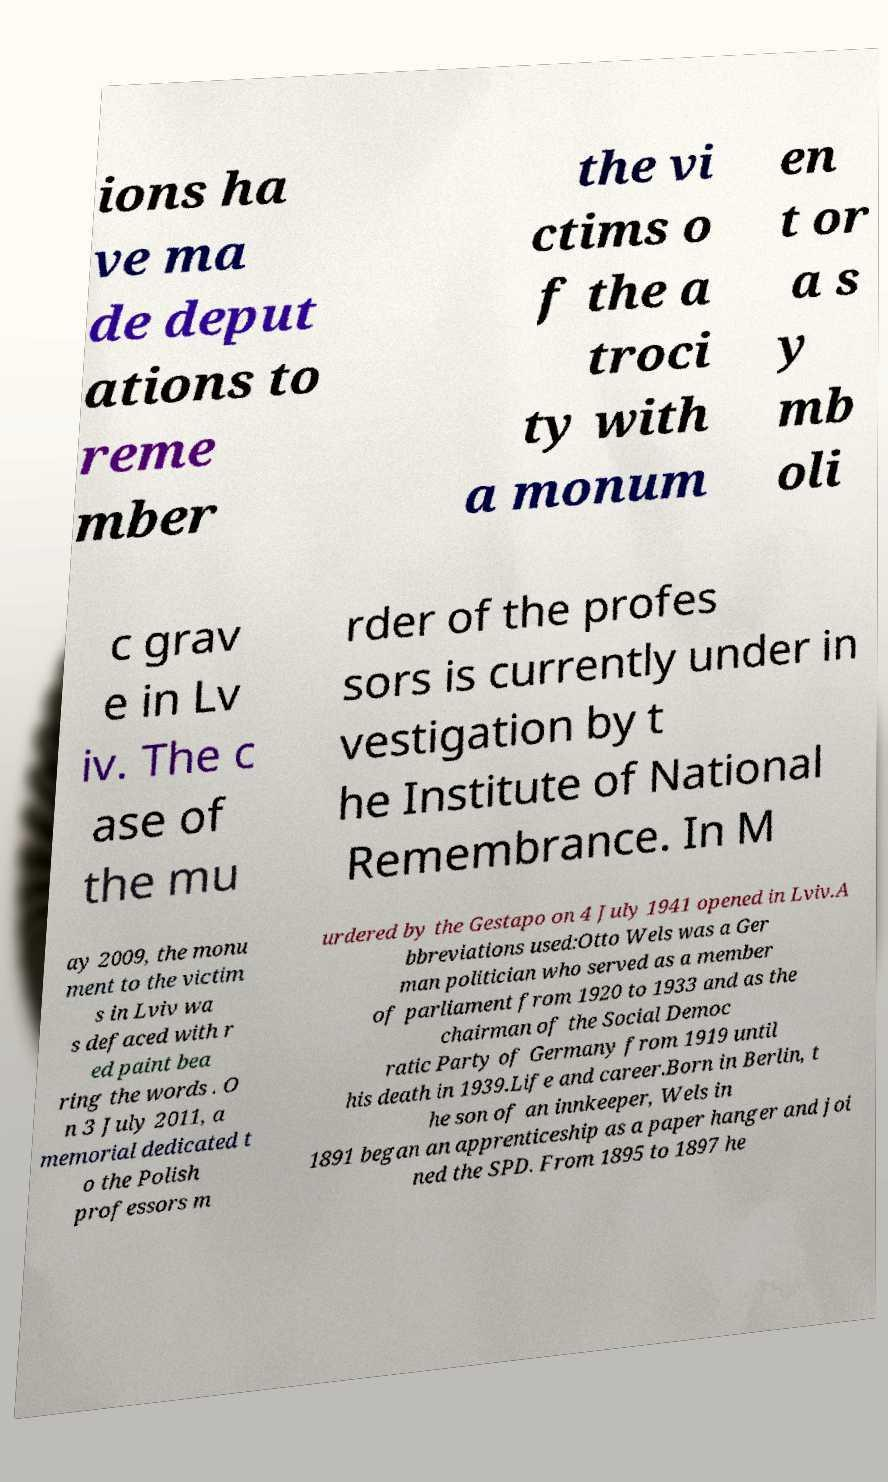There's text embedded in this image that I need extracted. Can you transcribe it verbatim? ions ha ve ma de deput ations to reme mber the vi ctims o f the a troci ty with a monum en t or a s y mb oli c grav e in Lv iv. The c ase of the mu rder of the profes sors is currently under in vestigation by t he Institute of National Remembrance. In M ay 2009, the monu ment to the victim s in Lviv wa s defaced with r ed paint bea ring the words . O n 3 July 2011, a memorial dedicated t o the Polish professors m urdered by the Gestapo on 4 July 1941 opened in Lviv.A bbreviations used:Otto Wels was a Ger man politician who served as a member of parliament from 1920 to 1933 and as the chairman of the Social Democ ratic Party of Germany from 1919 until his death in 1939.Life and career.Born in Berlin, t he son of an innkeeper, Wels in 1891 began an apprenticeship as a paper hanger and joi ned the SPD. From 1895 to 1897 he 